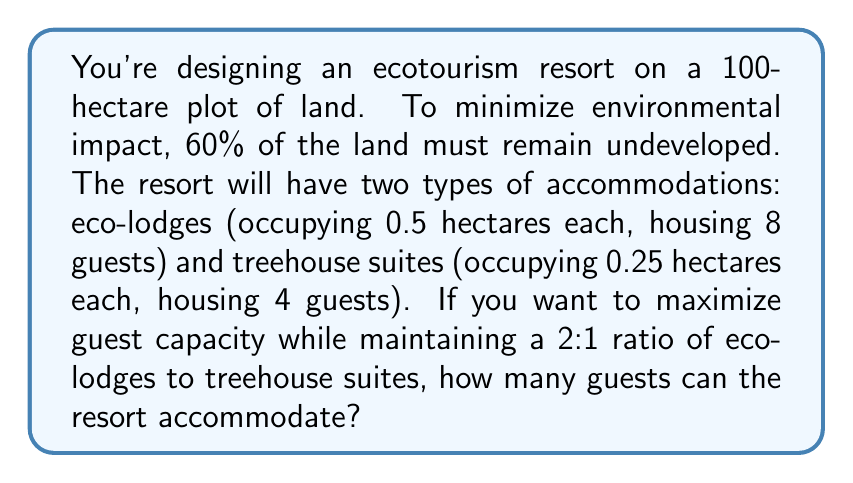Could you help me with this problem? Let's approach this step-by-step:

1) First, calculate the area available for development:
   $100 \text{ hectares} \times 0.4 = 40 \text{ hectares}$

2) Let $x$ be the number of eco-lodges. Then, the number of treehouse suites is $\frac{x}{2}$ (to maintain the 2:1 ratio).

3) Set up an equation for the total area used:
   $$0.5x + 0.25(\frac{x}{2}) = 40$$

4) Simplify the equation:
   $$0.5x + 0.125x = 40$$
   $$0.625x = 40$$

5) Solve for $x$:
   $$x = \frac{40}{0.625} = 64$$

6) So, there will be 64 eco-lodges and 32 treehouse suites.

7) Calculate the total number of guests:
   Eco-lodges: $64 \times 8 = 512$ guests
   Treehouse suites: $32 \times 4 = 128$ guests

8) Total guests: $512 + 128 = 640$
Answer: 640 guests 